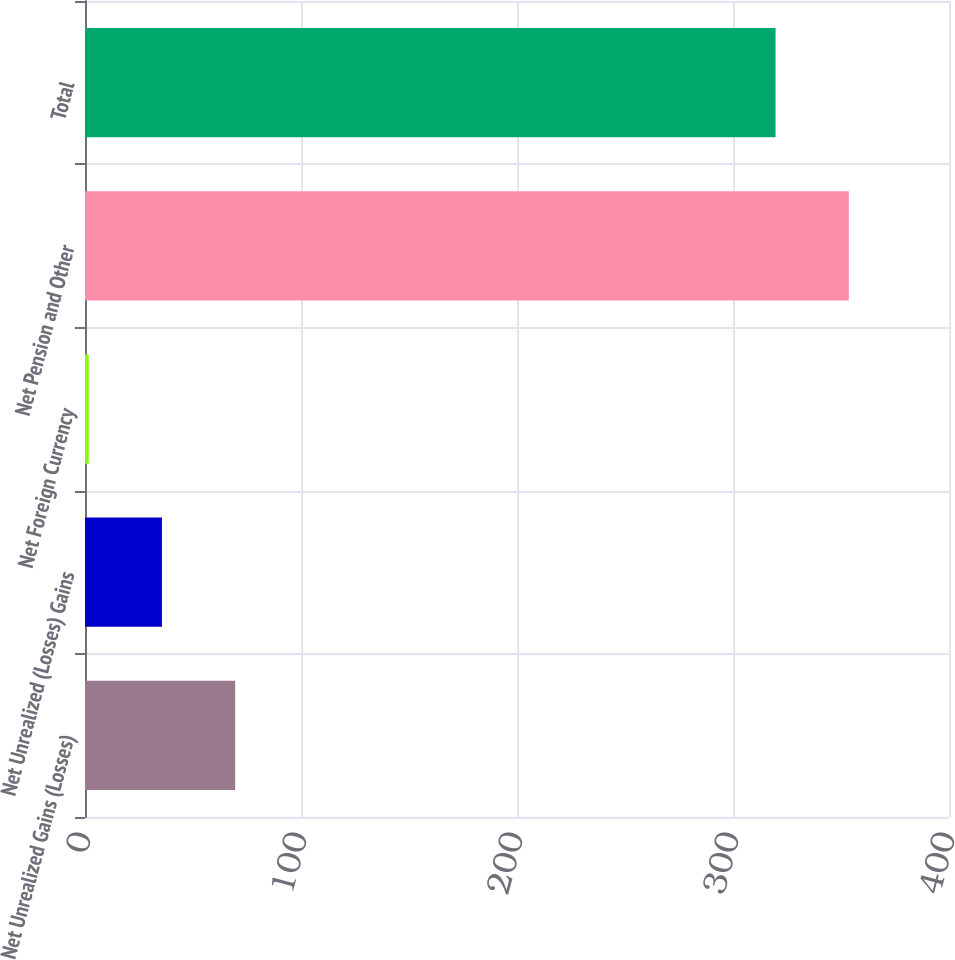<chart> <loc_0><loc_0><loc_500><loc_500><bar_chart><fcel>Net Unrealized Gains (Losses)<fcel>Net Unrealized (Losses) Gains<fcel>Net Foreign Currency<fcel>Net Pension and Other<fcel>Total<nl><fcel>69.54<fcel>35.62<fcel>1.7<fcel>353.62<fcel>319.7<nl></chart> 